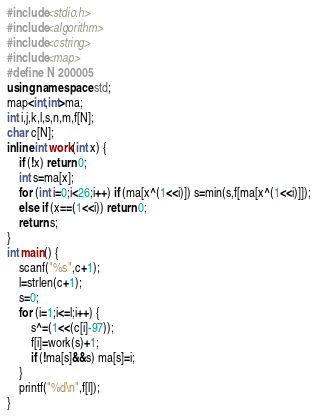<code> <loc_0><loc_0><loc_500><loc_500><_C++_>#include<stdio.h>
#include<algorithm>
#include<cstring>
#include<map>
#define N 200005
using namespace std;
map<int,int>ma;
int i,j,k,l,s,n,m,f[N];
char c[N];
inline int work(int x) {
    if (!x) return 0;
    int s=ma[x];
    for (int i=0;i<26;i++) if (ma[x^(1<<i)]) s=min(s,f[ma[x^(1<<i)]]);
    else if (x==(1<<i)) return 0;
    return s;
}
int main() {
    scanf("%s",c+1);
    l=strlen(c+1);
    s=0;
    for (i=1;i<=l;i++) {
        s^=(1<<(c[i]-97));
        f[i]=work(s)+1;
        if (!ma[s]&&s) ma[s]=i;
    }
    printf("%d\n",f[l]);
}
</code> 